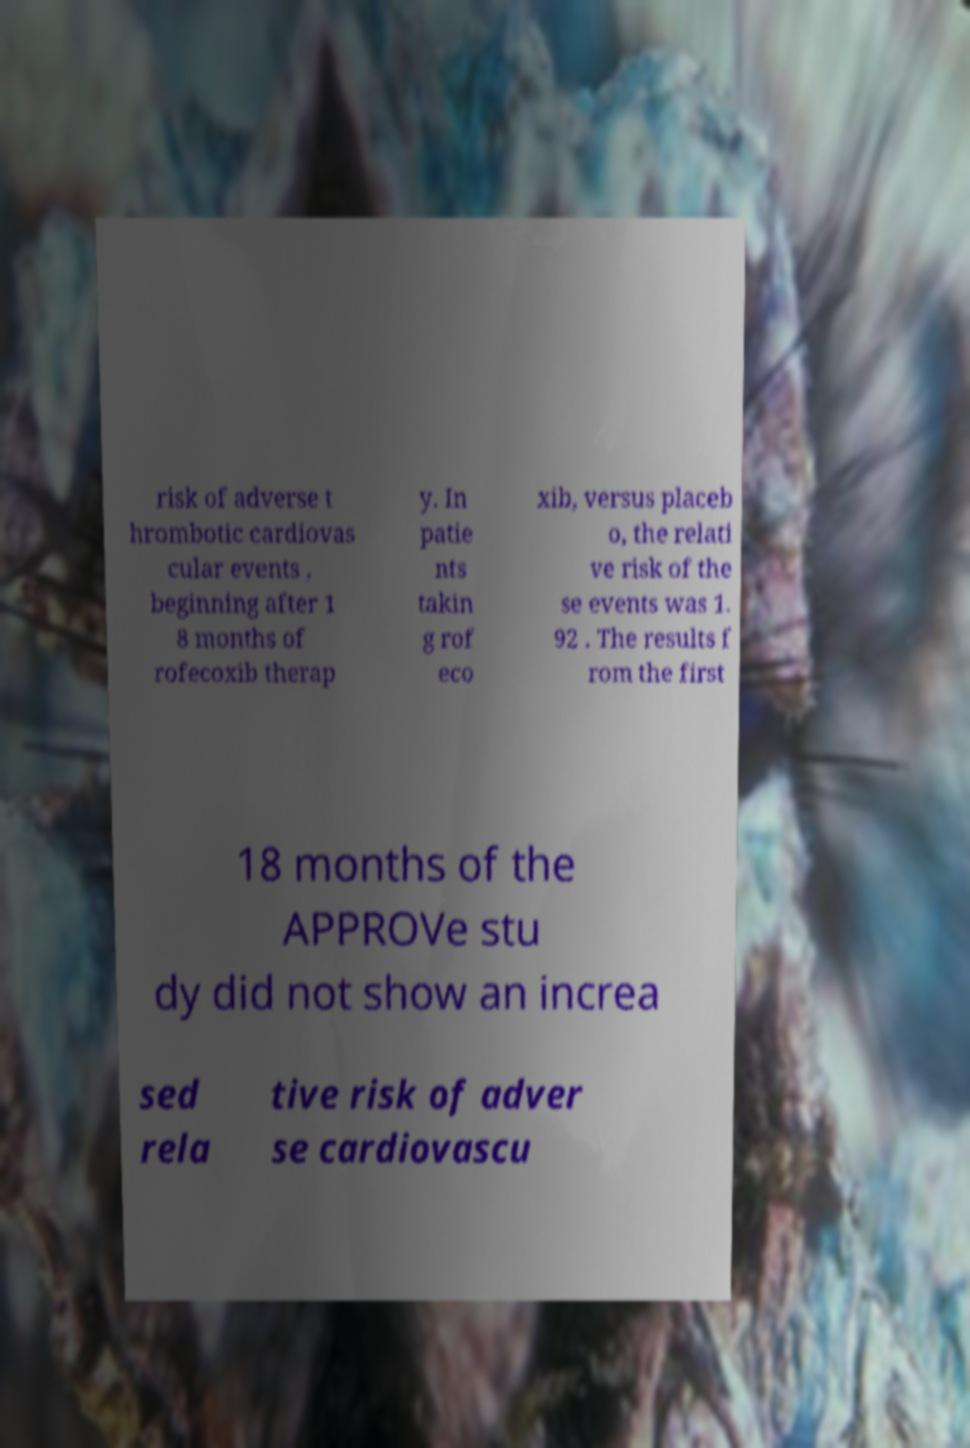There's text embedded in this image that I need extracted. Can you transcribe it verbatim? risk of adverse t hrombotic cardiovas cular events , beginning after 1 8 months of rofecoxib therap y. In patie nts takin g rof eco xib, versus placeb o, the relati ve risk of the se events was 1. 92 . The results f rom the first 18 months of the APPROVe stu dy did not show an increa sed rela tive risk of adver se cardiovascu 